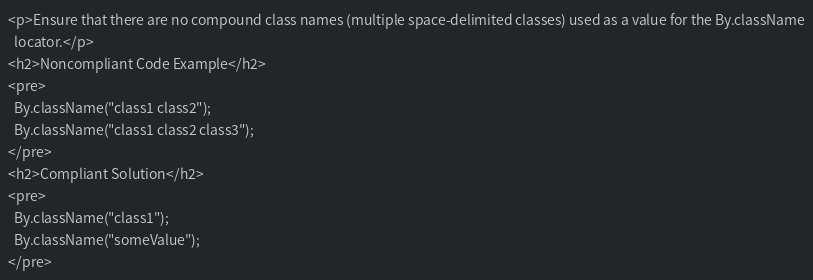<code> <loc_0><loc_0><loc_500><loc_500><_HTML_><p>Ensure that there are no compound class names (multiple space-delimited classes) used as a value for the By.className
  locator.</p>
<h2>Noncompliant Code Example</h2>
<pre>
  By.className("class1 class2");
  By.className("class1 class2 class3");
</pre>
<h2>Compliant Solution</h2>
<pre>
  By.className("class1");
  By.className("someValue");
</pre>
</code> 